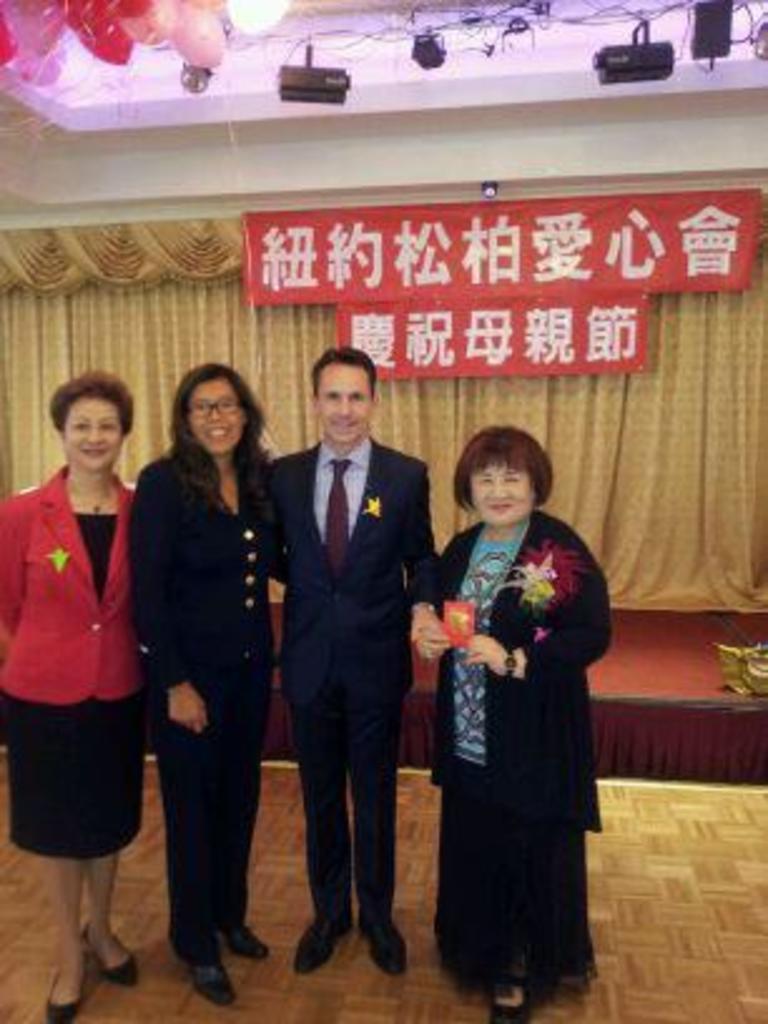Please provide a concise description of this image. In this picture we can see four persons are standing and smiling, in the background there is some text and a curtain, we can see balloons and some wires at the top of the picture, a woman on the right side is holding something. 